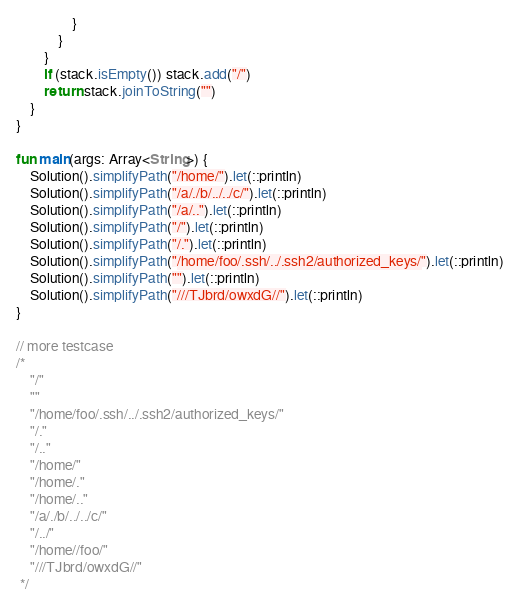<code> <loc_0><loc_0><loc_500><loc_500><_Kotlin_>                }
            }
        }
        if (stack.isEmpty()) stack.add("/")
        return stack.joinToString("")
    }
}

fun main(args: Array<String>) {
    Solution().simplifyPath("/home/").let(::println)
    Solution().simplifyPath("/a/./b/../../c/").let(::println)
    Solution().simplifyPath("/a/..").let(::println)
    Solution().simplifyPath("/").let(::println)
    Solution().simplifyPath("/.").let(::println)
    Solution().simplifyPath("/home/foo/.ssh/../.ssh2/authorized_keys/").let(::println)
    Solution().simplifyPath("").let(::println)
    Solution().simplifyPath("///TJbrd/owxdG//").let(::println)
}

// more testcase
/*
    "/"
    ""
    "/home/foo/.ssh/../.ssh2/authorized_keys/"
    "/."
    "/.."
    "/home/"
    "/home/."
    "/home/.."
    "/a/./b/../../c/"
    "/../"
    "/home//foo/"
    "///TJbrd/owxdG//"
 */</code> 